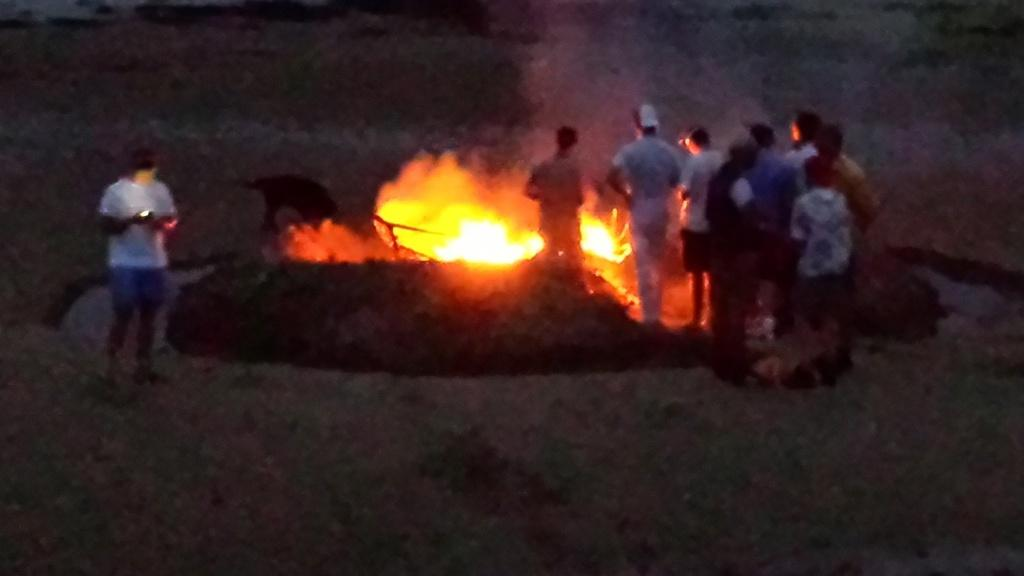What is happening in the image? There are people standing in the image, and there is a fire in the center. Can you describe the lighting in the image? The image appears to be slightly dark. What type of stew is being prepared by the father in the image? There is no father or stew present in the image. How does the fire change color as it burns in the image? The fire does not change color in the image; it remains consistently the same. 